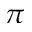Convert formula to latex. <formula><loc_0><loc_0><loc_500><loc_500>\pi</formula> 